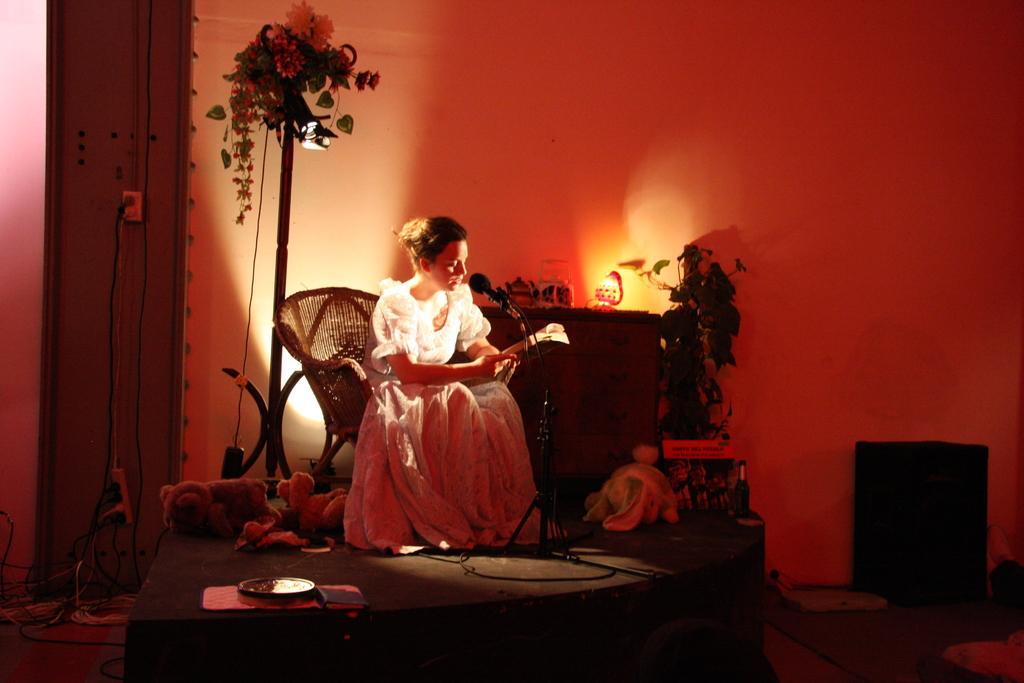In one or two sentences, can you explain what this image depicts? This picture shows a woman seated on the chair and holding a book in her hand and speaking with the help of a microphone and we see couple of plants 